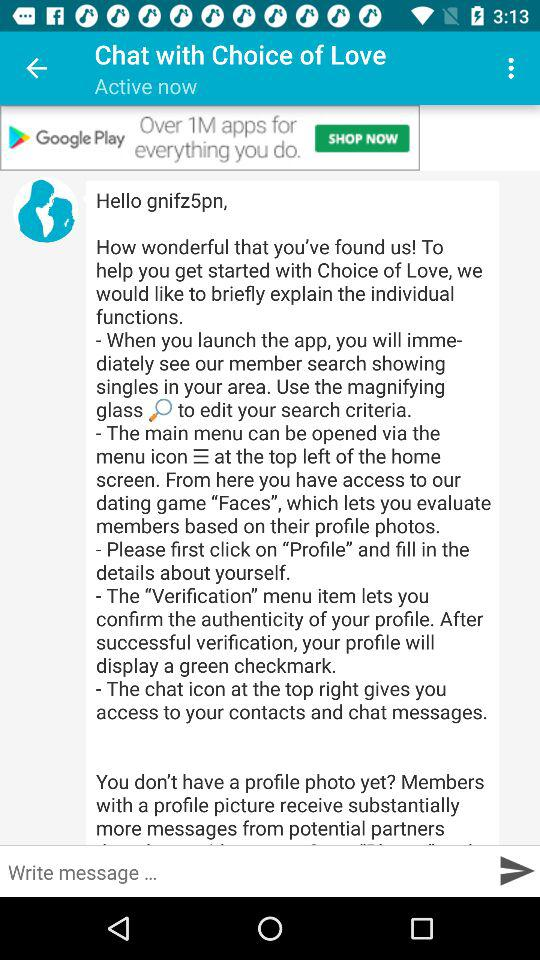What is the status of the user? The status is "Active". 